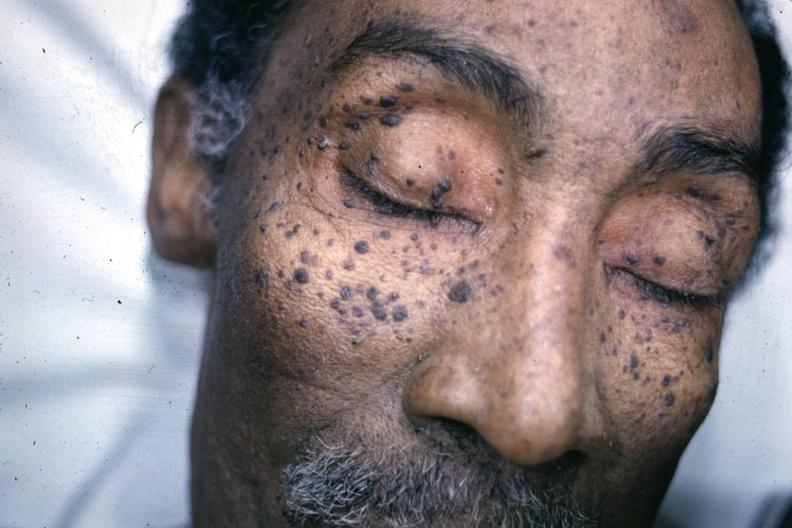what does this image show?
Answer the question using a single word or phrase. Photo of face with multiple typical lesions 